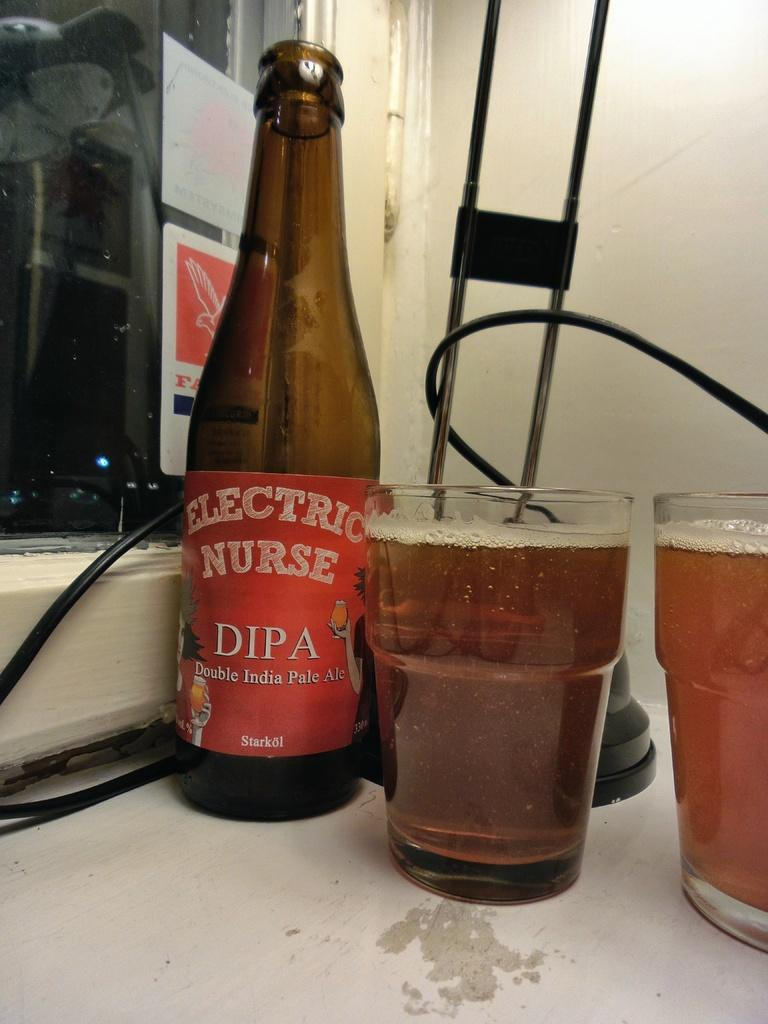<image>
Provide a brief description of the given image. Two pint glasses of beer are next to an empty bottle of Electric Nurse double IPA. 